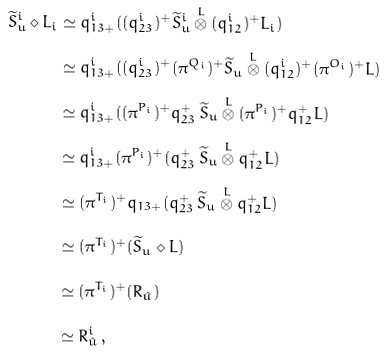Convert formula to latex. <formula><loc_0><loc_0><loc_500><loc_500>\widetilde { S } ^ { i } _ { u } \diamond L _ { i } & \simeq q ^ { i } _ { 1 3 + } ( ( q _ { 2 3 } ^ { i } ) ^ { + } \widetilde { S } ^ { i } _ { u } \overset { L } { \otimes } ( q _ { 1 2 } ^ { i } ) ^ { + } L _ { i } ) \\ & \simeq q ^ { i } _ { 1 3 + } ( ( q _ { 2 3 } ^ { i } ) ^ { + } ( \pi ^ { Q _ { i } } ) ^ { + } \widetilde { S } _ { u } \overset { L } { \otimes } ( q _ { 1 2 } ^ { i } ) ^ { + } ( \pi ^ { O _ { i } } ) ^ { + } L ) \\ & \simeq q ^ { i } _ { 1 3 + } ( ( \pi ^ { P _ { i } } ) ^ { + } q _ { 2 3 } ^ { + } \, \widetilde { S } _ { u } \overset { L } { \otimes } ( \pi ^ { P _ { i } } ) ^ { + } q _ { 1 2 } ^ { + } L ) \\ & \simeq q ^ { i } _ { 1 3 + } ( \pi ^ { P _ { i } } ) ^ { + } ( q _ { 2 3 } ^ { + } \, \widetilde { S } _ { u } \overset { L } { \otimes } q _ { 1 2 } ^ { + } L ) \\ & \simeq ( \pi ^ { T _ { i } } ) ^ { + } q _ { 1 3 + } ( q _ { 2 3 } ^ { + } \, \widetilde { S } _ { u } \overset { L } { \otimes } q _ { 1 2 } ^ { + } L ) \\ & \simeq ( \pi ^ { T _ { i } } ) ^ { + } ( \widetilde { S } _ { u } \diamond L ) \\ & \simeq ( \pi ^ { T _ { i } } ) ^ { + } ( R _ { \hat { u } } ) \\ & \simeq R ^ { i } _ { \hat { u } } \, ,</formula> 